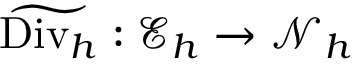Convert formula to latex. <formula><loc_0><loc_0><loc_500><loc_500>\widetilde { D i v _ { h } } \colon \mathcal { E } _ { h } \rightarrow \mathcal { N } _ { h }</formula> 